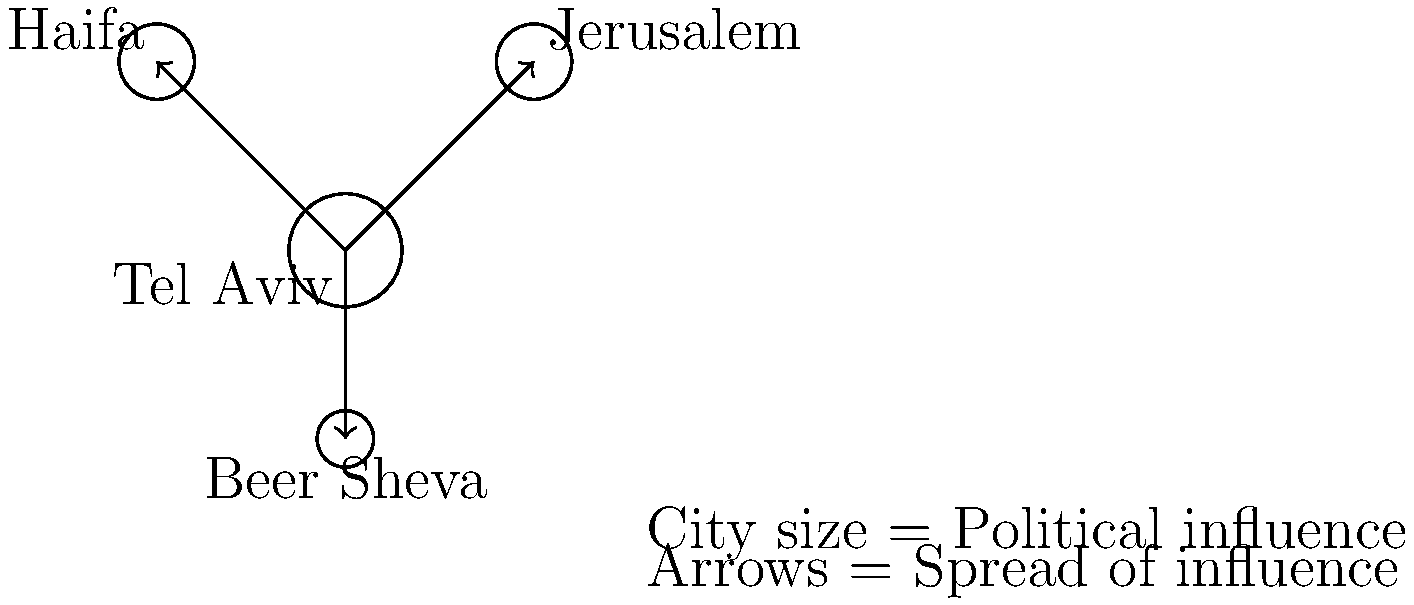Based on the map showing the spread of political influence from urban centers in Israel, which city appears to have the most significant impact on surrounding areas, and how might this influence the electoral patterns in the country? To answer this question, we need to analyze the given map step-by-step:

1. City sizes: The map represents cities as circles, with larger circles indicating greater political influence. Tel Aviv is shown with the largest circle, followed by Jerusalem and Haifa (equal size), and then Beer Sheva (smallest).

2. Influence arrows: Arrows originating from Tel Aviv point to all other cities, indicating that Tel Aviv's political influence spreads to Jerusalem, Haifa, and Beer Sheva.

3. Centrality: Tel Aviv is positioned centrally in the map, with connections to all other cities, reinforcing its role as a hub of political influence.

4. Historical context: Tel Aviv, as Israel's economic center and most populous metropolitan area, has traditionally been a stronghold of secular, centrist, and left-leaning politics.

5. Electoral implications: 
   a) Tel Aviv's influence might lead to a stronger showing for centrist and left-leaning parties in surrounding areas.
   b) The spread of Tel Aviv's influence to other major cities could result in a more uniform voting pattern across urban areas.
   c) Rural areas not directly connected to Tel Aviv might show different voting patterns, potentially favoring more conservative or religious parties.

6. Counterbalances: Despite Tel Aviv's apparent dominance, Jerusalem's religious and historical significance, and Haifa's diverse population could provide some resistance to Tel Aviv's influence, maintaining distinct local political characteristics.

Given this analysis, Tel Aviv appears to have the most significant impact on surrounding areas, potentially homogenizing urban voting patterns while accentuating urban-rural political divides.
Answer: Tel Aviv; homogenizing urban votes, accentuating urban-rural divides 